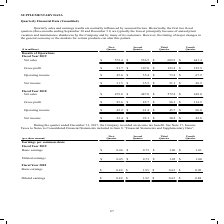According to Carpenter Technology's financial document, What are Quarterly sales and earnings results normally influenced by? According to the financial document, seasonal factors. The relevant text states: "s and earnings results are normally influenced by seasonal factors. Historically, the first two fiscal quarters (three months ending September 30 and December 31) are..." Also, Why are the first two fiscal quarters typically the lowest? principally because of annual plant vacation and maintenance shutdowns by the Company and by many of its customers. However, the timing of major changes in the general economy or the markets for certain products can alter this pattern.. The document states: "ember 30 and December 31) are typically the lowest principally because of annual plant vacation and maintenance shutdowns by the Company and by many o..." Also, What is the net sales for 2019 for each quarter in chronological order? The document contains multiple relevant values: $572.4, $556.5, $609.9, $641.4 (in millions). From the document: "f Operations Fiscal Year 2019 Net sales $ 572.4 $ 556.5 $ 609.9 $ 641.4 cal Year 2019 Net sales $ 572.4 $ 556.5 $ 609.9 $ 641.4 ions Fiscal Year 2019 ..." Additionally, Which quarter was the net income in 2019 the largest? According to the financial document, Third Quarter. The relevant text states: "($ in millions) First Quarter Second Quarter Third Quarter Fourth Quarter Results of Operations Fiscal Year 2019 Net sales $ 572.4 $ 556.5 $ 609.9 $ 641.4..." Also, can you calculate: What was the change in net income in First Quarter in 2019 from 2018? Based on the calculation: 31.5-23.4, the result is 8.1 (in millions). This is based on the information: "Net income $ 31.5 $ 35.5 $ 51.1 $ 48.9 Net income $ 23.4 $ 92.1 $ 30.2 $ 42.8..." The key data points involved are: 23.4, 31.5. Also, can you calculate: What was the percentage change in net income in First Quarter in 2019 from 2018? To answer this question, I need to perform calculations using the financial data. The calculation is: (31.5-23.4)/23.4, which equals 34.62 (percentage). This is based on the information: "Net income $ 31.5 $ 35.5 $ 51.1 $ 48.9 Net income $ 23.4 $ 92.1 $ 30.2 $ 42.8..." The key data points involved are: 23.4, 31.5. 